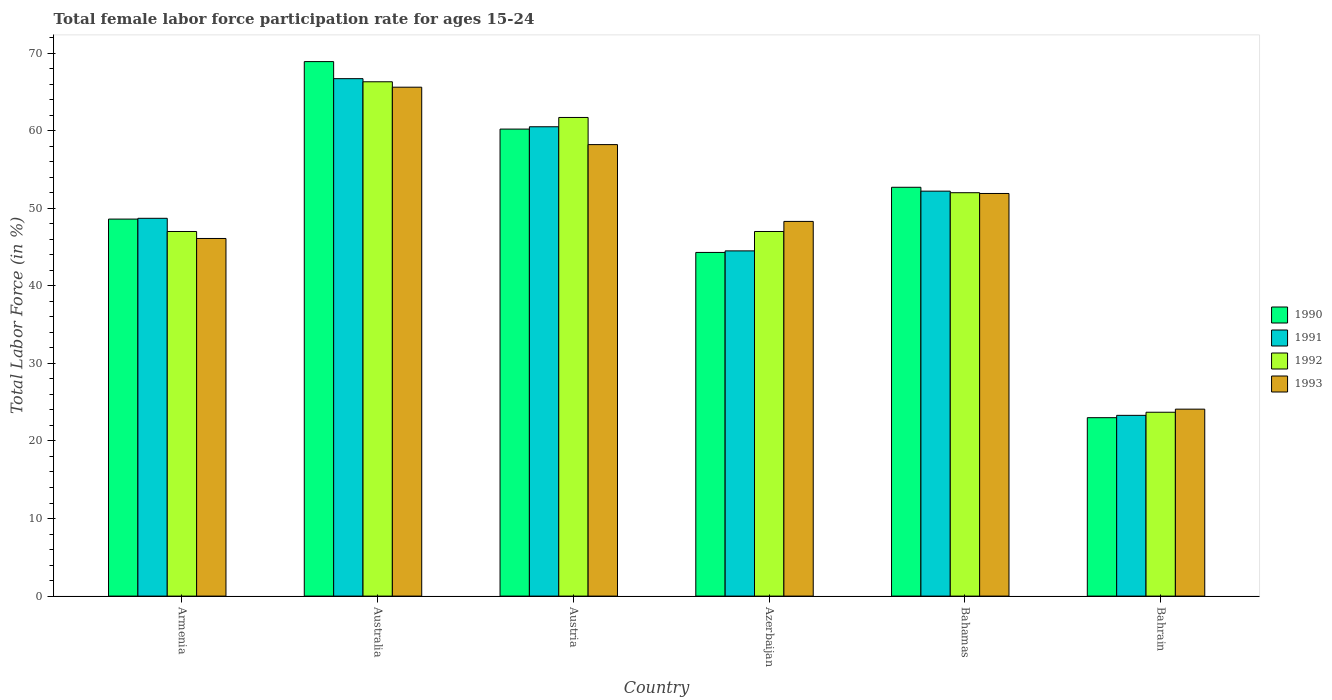How many different coloured bars are there?
Provide a succinct answer. 4. Are the number of bars on each tick of the X-axis equal?
Provide a succinct answer. Yes. How many bars are there on the 1st tick from the right?
Your response must be concise. 4. In how many cases, is the number of bars for a given country not equal to the number of legend labels?
Ensure brevity in your answer.  0. What is the female labor force participation rate in 1991 in Bahamas?
Ensure brevity in your answer.  52.2. Across all countries, what is the maximum female labor force participation rate in 1993?
Your answer should be compact. 65.6. Across all countries, what is the minimum female labor force participation rate in 1993?
Keep it short and to the point. 24.1. In which country was the female labor force participation rate in 1990 minimum?
Provide a short and direct response. Bahrain. What is the total female labor force participation rate in 1991 in the graph?
Offer a very short reply. 295.9. What is the difference between the female labor force participation rate in 1990 in Austria and that in Azerbaijan?
Offer a terse response. 15.9. What is the difference between the female labor force participation rate in 1992 in Austria and the female labor force participation rate in 1990 in Azerbaijan?
Your answer should be very brief. 17.4. What is the average female labor force participation rate in 1992 per country?
Your response must be concise. 49.62. What is the difference between the female labor force participation rate of/in 1991 and female labor force participation rate of/in 1993 in Australia?
Provide a succinct answer. 1.1. What is the ratio of the female labor force participation rate in 1991 in Armenia to that in Azerbaijan?
Make the answer very short. 1.09. Is the female labor force participation rate in 1993 in Armenia less than that in Azerbaijan?
Give a very brief answer. Yes. What is the difference between the highest and the second highest female labor force participation rate in 1992?
Make the answer very short. 14.3. What is the difference between the highest and the lowest female labor force participation rate in 1992?
Offer a terse response. 42.6. Is it the case that in every country, the sum of the female labor force participation rate in 1991 and female labor force participation rate in 1990 is greater than the sum of female labor force participation rate in 1992 and female labor force participation rate in 1993?
Provide a short and direct response. No. What does the 2nd bar from the right in Australia represents?
Give a very brief answer. 1992. Is it the case that in every country, the sum of the female labor force participation rate in 1993 and female labor force participation rate in 1992 is greater than the female labor force participation rate in 1991?
Your answer should be compact. Yes. Are all the bars in the graph horizontal?
Offer a terse response. No. How many countries are there in the graph?
Provide a short and direct response. 6. Are the values on the major ticks of Y-axis written in scientific E-notation?
Provide a succinct answer. No. Does the graph contain any zero values?
Your response must be concise. No. Where does the legend appear in the graph?
Give a very brief answer. Center right. How are the legend labels stacked?
Keep it short and to the point. Vertical. What is the title of the graph?
Provide a short and direct response. Total female labor force participation rate for ages 15-24. What is the Total Labor Force (in %) of 1990 in Armenia?
Make the answer very short. 48.6. What is the Total Labor Force (in %) in 1991 in Armenia?
Make the answer very short. 48.7. What is the Total Labor Force (in %) of 1992 in Armenia?
Your answer should be compact. 47. What is the Total Labor Force (in %) of 1993 in Armenia?
Your answer should be compact. 46.1. What is the Total Labor Force (in %) of 1990 in Australia?
Provide a short and direct response. 68.9. What is the Total Labor Force (in %) of 1991 in Australia?
Your answer should be very brief. 66.7. What is the Total Labor Force (in %) of 1992 in Australia?
Give a very brief answer. 66.3. What is the Total Labor Force (in %) of 1993 in Australia?
Offer a terse response. 65.6. What is the Total Labor Force (in %) of 1990 in Austria?
Make the answer very short. 60.2. What is the Total Labor Force (in %) in 1991 in Austria?
Give a very brief answer. 60.5. What is the Total Labor Force (in %) of 1992 in Austria?
Your response must be concise. 61.7. What is the Total Labor Force (in %) of 1993 in Austria?
Make the answer very short. 58.2. What is the Total Labor Force (in %) of 1990 in Azerbaijan?
Ensure brevity in your answer.  44.3. What is the Total Labor Force (in %) in 1991 in Azerbaijan?
Ensure brevity in your answer.  44.5. What is the Total Labor Force (in %) of 1993 in Azerbaijan?
Offer a terse response. 48.3. What is the Total Labor Force (in %) in 1990 in Bahamas?
Give a very brief answer. 52.7. What is the Total Labor Force (in %) in 1991 in Bahamas?
Make the answer very short. 52.2. What is the Total Labor Force (in %) of 1992 in Bahamas?
Offer a very short reply. 52. What is the Total Labor Force (in %) of 1993 in Bahamas?
Your answer should be very brief. 51.9. What is the Total Labor Force (in %) of 1991 in Bahrain?
Keep it short and to the point. 23.3. What is the Total Labor Force (in %) in 1992 in Bahrain?
Your answer should be compact. 23.7. What is the Total Labor Force (in %) in 1993 in Bahrain?
Your answer should be very brief. 24.1. Across all countries, what is the maximum Total Labor Force (in %) in 1990?
Make the answer very short. 68.9. Across all countries, what is the maximum Total Labor Force (in %) in 1991?
Offer a very short reply. 66.7. Across all countries, what is the maximum Total Labor Force (in %) in 1992?
Your answer should be very brief. 66.3. Across all countries, what is the maximum Total Labor Force (in %) in 1993?
Provide a short and direct response. 65.6. Across all countries, what is the minimum Total Labor Force (in %) of 1990?
Ensure brevity in your answer.  23. Across all countries, what is the minimum Total Labor Force (in %) in 1991?
Keep it short and to the point. 23.3. Across all countries, what is the minimum Total Labor Force (in %) in 1992?
Provide a short and direct response. 23.7. Across all countries, what is the minimum Total Labor Force (in %) of 1993?
Your answer should be compact. 24.1. What is the total Total Labor Force (in %) in 1990 in the graph?
Your response must be concise. 297.7. What is the total Total Labor Force (in %) of 1991 in the graph?
Make the answer very short. 295.9. What is the total Total Labor Force (in %) of 1992 in the graph?
Your answer should be very brief. 297.7. What is the total Total Labor Force (in %) of 1993 in the graph?
Keep it short and to the point. 294.2. What is the difference between the Total Labor Force (in %) in 1990 in Armenia and that in Australia?
Offer a very short reply. -20.3. What is the difference between the Total Labor Force (in %) of 1991 in Armenia and that in Australia?
Offer a very short reply. -18. What is the difference between the Total Labor Force (in %) in 1992 in Armenia and that in Australia?
Keep it short and to the point. -19.3. What is the difference between the Total Labor Force (in %) in 1993 in Armenia and that in Australia?
Give a very brief answer. -19.5. What is the difference between the Total Labor Force (in %) in 1990 in Armenia and that in Austria?
Make the answer very short. -11.6. What is the difference between the Total Labor Force (in %) in 1991 in Armenia and that in Austria?
Provide a succinct answer. -11.8. What is the difference between the Total Labor Force (in %) in 1992 in Armenia and that in Austria?
Make the answer very short. -14.7. What is the difference between the Total Labor Force (in %) of 1990 in Armenia and that in Azerbaijan?
Make the answer very short. 4.3. What is the difference between the Total Labor Force (in %) of 1991 in Armenia and that in Azerbaijan?
Keep it short and to the point. 4.2. What is the difference between the Total Labor Force (in %) in 1992 in Armenia and that in Azerbaijan?
Your response must be concise. 0. What is the difference between the Total Labor Force (in %) in 1990 in Armenia and that in Bahamas?
Make the answer very short. -4.1. What is the difference between the Total Labor Force (in %) of 1990 in Armenia and that in Bahrain?
Offer a very short reply. 25.6. What is the difference between the Total Labor Force (in %) in 1991 in Armenia and that in Bahrain?
Your answer should be compact. 25.4. What is the difference between the Total Labor Force (in %) in 1992 in Armenia and that in Bahrain?
Offer a terse response. 23.3. What is the difference between the Total Labor Force (in %) of 1993 in Armenia and that in Bahrain?
Offer a terse response. 22. What is the difference between the Total Labor Force (in %) in 1993 in Australia and that in Austria?
Your answer should be compact. 7.4. What is the difference between the Total Labor Force (in %) in 1990 in Australia and that in Azerbaijan?
Your answer should be very brief. 24.6. What is the difference between the Total Labor Force (in %) of 1992 in Australia and that in Azerbaijan?
Your response must be concise. 19.3. What is the difference between the Total Labor Force (in %) of 1993 in Australia and that in Azerbaijan?
Make the answer very short. 17.3. What is the difference between the Total Labor Force (in %) of 1990 in Australia and that in Bahamas?
Your response must be concise. 16.2. What is the difference between the Total Labor Force (in %) of 1990 in Australia and that in Bahrain?
Provide a short and direct response. 45.9. What is the difference between the Total Labor Force (in %) of 1991 in Australia and that in Bahrain?
Offer a terse response. 43.4. What is the difference between the Total Labor Force (in %) in 1992 in Australia and that in Bahrain?
Give a very brief answer. 42.6. What is the difference between the Total Labor Force (in %) of 1993 in Australia and that in Bahrain?
Give a very brief answer. 41.5. What is the difference between the Total Labor Force (in %) in 1991 in Austria and that in Azerbaijan?
Your answer should be very brief. 16. What is the difference between the Total Labor Force (in %) in 1990 in Austria and that in Bahamas?
Offer a terse response. 7.5. What is the difference between the Total Labor Force (in %) in 1991 in Austria and that in Bahamas?
Give a very brief answer. 8.3. What is the difference between the Total Labor Force (in %) in 1990 in Austria and that in Bahrain?
Ensure brevity in your answer.  37.2. What is the difference between the Total Labor Force (in %) of 1991 in Austria and that in Bahrain?
Provide a succinct answer. 37.2. What is the difference between the Total Labor Force (in %) of 1993 in Austria and that in Bahrain?
Offer a very short reply. 34.1. What is the difference between the Total Labor Force (in %) of 1991 in Azerbaijan and that in Bahamas?
Provide a succinct answer. -7.7. What is the difference between the Total Labor Force (in %) of 1992 in Azerbaijan and that in Bahamas?
Provide a short and direct response. -5. What is the difference between the Total Labor Force (in %) of 1990 in Azerbaijan and that in Bahrain?
Offer a terse response. 21.3. What is the difference between the Total Labor Force (in %) in 1991 in Azerbaijan and that in Bahrain?
Your response must be concise. 21.2. What is the difference between the Total Labor Force (in %) in 1992 in Azerbaijan and that in Bahrain?
Your answer should be compact. 23.3. What is the difference between the Total Labor Force (in %) in 1993 in Azerbaijan and that in Bahrain?
Provide a succinct answer. 24.2. What is the difference between the Total Labor Force (in %) in 1990 in Bahamas and that in Bahrain?
Ensure brevity in your answer.  29.7. What is the difference between the Total Labor Force (in %) of 1991 in Bahamas and that in Bahrain?
Make the answer very short. 28.9. What is the difference between the Total Labor Force (in %) in 1992 in Bahamas and that in Bahrain?
Offer a very short reply. 28.3. What is the difference between the Total Labor Force (in %) in 1993 in Bahamas and that in Bahrain?
Offer a very short reply. 27.8. What is the difference between the Total Labor Force (in %) of 1990 in Armenia and the Total Labor Force (in %) of 1991 in Australia?
Keep it short and to the point. -18.1. What is the difference between the Total Labor Force (in %) of 1990 in Armenia and the Total Labor Force (in %) of 1992 in Australia?
Your answer should be compact. -17.7. What is the difference between the Total Labor Force (in %) of 1990 in Armenia and the Total Labor Force (in %) of 1993 in Australia?
Your response must be concise. -17. What is the difference between the Total Labor Force (in %) in 1991 in Armenia and the Total Labor Force (in %) in 1992 in Australia?
Offer a very short reply. -17.6. What is the difference between the Total Labor Force (in %) of 1991 in Armenia and the Total Labor Force (in %) of 1993 in Australia?
Give a very brief answer. -16.9. What is the difference between the Total Labor Force (in %) in 1992 in Armenia and the Total Labor Force (in %) in 1993 in Australia?
Provide a short and direct response. -18.6. What is the difference between the Total Labor Force (in %) of 1990 in Armenia and the Total Labor Force (in %) of 1991 in Austria?
Your answer should be very brief. -11.9. What is the difference between the Total Labor Force (in %) in 1990 in Armenia and the Total Labor Force (in %) in 1993 in Austria?
Keep it short and to the point. -9.6. What is the difference between the Total Labor Force (in %) of 1991 in Armenia and the Total Labor Force (in %) of 1992 in Austria?
Ensure brevity in your answer.  -13. What is the difference between the Total Labor Force (in %) in 1992 in Armenia and the Total Labor Force (in %) in 1993 in Austria?
Your answer should be compact. -11.2. What is the difference between the Total Labor Force (in %) of 1991 in Armenia and the Total Labor Force (in %) of 1992 in Azerbaijan?
Provide a succinct answer. 1.7. What is the difference between the Total Labor Force (in %) of 1992 in Armenia and the Total Labor Force (in %) of 1993 in Azerbaijan?
Your answer should be very brief. -1.3. What is the difference between the Total Labor Force (in %) in 1990 in Armenia and the Total Labor Force (in %) in 1991 in Bahamas?
Provide a succinct answer. -3.6. What is the difference between the Total Labor Force (in %) of 1990 in Armenia and the Total Labor Force (in %) of 1993 in Bahamas?
Your answer should be very brief. -3.3. What is the difference between the Total Labor Force (in %) of 1992 in Armenia and the Total Labor Force (in %) of 1993 in Bahamas?
Provide a succinct answer. -4.9. What is the difference between the Total Labor Force (in %) of 1990 in Armenia and the Total Labor Force (in %) of 1991 in Bahrain?
Make the answer very short. 25.3. What is the difference between the Total Labor Force (in %) of 1990 in Armenia and the Total Labor Force (in %) of 1992 in Bahrain?
Make the answer very short. 24.9. What is the difference between the Total Labor Force (in %) of 1990 in Armenia and the Total Labor Force (in %) of 1993 in Bahrain?
Provide a succinct answer. 24.5. What is the difference between the Total Labor Force (in %) of 1991 in Armenia and the Total Labor Force (in %) of 1992 in Bahrain?
Give a very brief answer. 25. What is the difference between the Total Labor Force (in %) in 1991 in Armenia and the Total Labor Force (in %) in 1993 in Bahrain?
Your answer should be very brief. 24.6. What is the difference between the Total Labor Force (in %) in 1992 in Armenia and the Total Labor Force (in %) in 1993 in Bahrain?
Make the answer very short. 22.9. What is the difference between the Total Labor Force (in %) in 1990 in Australia and the Total Labor Force (in %) in 1993 in Austria?
Your response must be concise. 10.7. What is the difference between the Total Labor Force (in %) in 1991 in Australia and the Total Labor Force (in %) in 1992 in Austria?
Give a very brief answer. 5. What is the difference between the Total Labor Force (in %) of 1991 in Australia and the Total Labor Force (in %) of 1993 in Austria?
Your answer should be compact. 8.5. What is the difference between the Total Labor Force (in %) in 1992 in Australia and the Total Labor Force (in %) in 1993 in Austria?
Your response must be concise. 8.1. What is the difference between the Total Labor Force (in %) in 1990 in Australia and the Total Labor Force (in %) in 1991 in Azerbaijan?
Provide a short and direct response. 24.4. What is the difference between the Total Labor Force (in %) of 1990 in Australia and the Total Labor Force (in %) of 1992 in Azerbaijan?
Your answer should be very brief. 21.9. What is the difference between the Total Labor Force (in %) in 1990 in Australia and the Total Labor Force (in %) in 1993 in Azerbaijan?
Provide a succinct answer. 20.6. What is the difference between the Total Labor Force (in %) in 1992 in Australia and the Total Labor Force (in %) in 1993 in Azerbaijan?
Offer a terse response. 18. What is the difference between the Total Labor Force (in %) in 1990 in Australia and the Total Labor Force (in %) in 1991 in Bahamas?
Your answer should be very brief. 16.7. What is the difference between the Total Labor Force (in %) in 1990 in Australia and the Total Labor Force (in %) in 1993 in Bahamas?
Provide a succinct answer. 17. What is the difference between the Total Labor Force (in %) in 1991 in Australia and the Total Labor Force (in %) in 1993 in Bahamas?
Offer a very short reply. 14.8. What is the difference between the Total Labor Force (in %) in 1992 in Australia and the Total Labor Force (in %) in 1993 in Bahamas?
Your response must be concise. 14.4. What is the difference between the Total Labor Force (in %) of 1990 in Australia and the Total Labor Force (in %) of 1991 in Bahrain?
Keep it short and to the point. 45.6. What is the difference between the Total Labor Force (in %) of 1990 in Australia and the Total Labor Force (in %) of 1992 in Bahrain?
Give a very brief answer. 45.2. What is the difference between the Total Labor Force (in %) in 1990 in Australia and the Total Labor Force (in %) in 1993 in Bahrain?
Offer a very short reply. 44.8. What is the difference between the Total Labor Force (in %) of 1991 in Australia and the Total Labor Force (in %) of 1993 in Bahrain?
Your answer should be very brief. 42.6. What is the difference between the Total Labor Force (in %) of 1992 in Australia and the Total Labor Force (in %) of 1993 in Bahrain?
Give a very brief answer. 42.2. What is the difference between the Total Labor Force (in %) in 1990 in Austria and the Total Labor Force (in %) in 1992 in Azerbaijan?
Your response must be concise. 13.2. What is the difference between the Total Labor Force (in %) in 1990 in Austria and the Total Labor Force (in %) in 1992 in Bahamas?
Offer a terse response. 8.2. What is the difference between the Total Labor Force (in %) of 1992 in Austria and the Total Labor Force (in %) of 1993 in Bahamas?
Provide a short and direct response. 9.8. What is the difference between the Total Labor Force (in %) of 1990 in Austria and the Total Labor Force (in %) of 1991 in Bahrain?
Offer a very short reply. 36.9. What is the difference between the Total Labor Force (in %) in 1990 in Austria and the Total Labor Force (in %) in 1992 in Bahrain?
Ensure brevity in your answer.  36.5. What is the difference between the Total Labor Force (in %) in 1990 in Austria and the Total Labor Force (in %) in 1993 in Bahrain?
Your answer should be very brief. 36.1. What is the difference between the Total Labor Force (in %) of 1991 in Austria and the Total Labor Force (in %) of 1992 in Bahrain?
Provide a succinct answer. 36.8. What is the difference between the Total Labor Force (in %) of 1991 in Austria and the Total Labor Force (in %) of 1993 in Bahrain?
Provide a short and direct response. 36.4. What is the difference between the Total Labor Force (in %) in 1992 in Austria and the Total Labor Force (in %) in 1993 in Bahrain?
Give a very brief answer. 37.6. What is the difference between the Total Labor Force (in %) of 1990 in Azerbaijan and the Total Labor Force (in %) of 1991 in Bahamas?
Keep it short and to the point. -7.9. What is the difference between the Total Labor Force (in %) of 1991 in Azerbaijan and the Total Labor Force (in %) of 1992 in Bahamas?
Keep it short and to the point. -7.5. What is the difference between the Total Labor Force (in %) of 1991 in Azerbaijan and the Total Labor Force (in %) of 1993 in Bahamas?
Your answer should be compact. -7.4. What is the difference between the Total Labor Force (in %) of 1990 in Azerbaijan and the Total Labor Force (in %) of 1991 in Bahrain?
Ensure brevity in your answer.  21. What is the difference between the Total Labor Force (in %) of 1990 in Azerbaijan and the Total Labor Force (in %) of 1992 in Bahrain?
Offer a very short reply. 20.6. What is the difference between the Total Labor Force (in %) in 1990 in Azerbaijan and the Total Labor Force (in %) in 1993 in Bahrain?
Provide a succinct answer. 20.2. What is the difference between the Total Labor Force (in %) of 1991 in Azerbaijan and the Total Labor Force (in %) of 1992 in Bahrain?
Provide a succinct answer. 20.8. What is the difference between the Total Labor Force (in %) of 1991 in Azerbaijan and the Total Labor Force (in %) of 1993 in Bahrain?
Your answer should be compact. 20.4. What is the difference between the Total Labor Force (in %) of 1992 in Azerbaijan and the Total Labor Force (in %) of 1993 in Bahrain?
Your answer should be compact. 22.9. What is the difference between the Total Labor Force (in %) in 1990 in Bahamas and the Total Labor Force (in %) in 1991 in Bahrain?
Offer a terse response. 29.4. What is the difference between the Total Labor Force (in %) in 1990 in Bahamas and the Total Labor Force (in %) in 1993 in Bahrain?
Keep it short and to the point. 28.6. What is the difference between the Total Labor Force (in %) of 1991 in Bahamas and the Total Labor Force (in %) of 1992 in Bahrain?
Your answer should be very brief. 28.5. What is the difference between the Total Labor Force (in %) of 1991 in Bahamas and the Total Labor Force (in %) of 1993 in Bahrain?
Provide a succinct answer. 28.1. What is the difference between the Total Labor Force (in %) in 1992 in Bahamas and the Total Labor Force (in %) in 1993 in Bahrain?
Provide a short and direct response. 27.9. What is the average Total Labor Force (in %) of 1990 per country?
Make the answer very short. 49.62. What is the average Total Labor Force (in %) in 1991 per country?
Give a very brief answer. 49.32. What is the average Total Labor Force (in %) in 1992 per country?
Give a very brief answer. 49.62. What is the average Total Labor Force (in %) in 1993 per country?
Provide a succinct answer. 49.03. What is the difference between the Total Labor Force (in %) in 1990 and Total Labor Force (in %) in 1992 in Armenia?
Offer a terse response. 1.6. What is the difference between the Total Labor Force (in %) of 1991 and Total Labor Force (in %) of 1992 in Armenia?
Provide a succinct answer. 1.7. What is the difference between the Total Labor Force (in %) in 1992 and Total Labor Force (in %) in 1993 in Armenia?
Make the answer very short. 0.9. What is the difference between the Total Labor Force (in %) of 1990 and Total Labor Force (in %) of 1991 in Australia?
Your response must be concise. 2.2. What is the difference between the Total Labor Force (in %) of 1990 and Total Labor Force (in %) of 1992 in Australia?
Ensure brevity in your answer.  2.6. What is the difference between the Total Labor Force (in %) in 1990 and Total Labor Force (in %) in 1993 in Australia?
Give a very brief answer. 3.3. What is the difference between the Total Labor Force (in %) of 1991 and Total Labor Force (in %) of 1993 in Australia?
Provide a short and direct response. 1.1. What is the difference between the Total Labor Force (in %) of 1990 and Total Labor Force (in %) of 1992 in Austria?
Your answer should be compact. -1.5. What is the difference between the Total Labor Force (in %) of 1991 and Total Labor Force (in %) of 1992 in Austria?
Offer a terse response. -1.2. What is the difference between the Total Labor Force (in %) in 1991 and Total Labor Force (in %) in 1993 in Austria?
Your response must be concise. 2.3. What is the difference between the Total Labor Force (in %) in 1992 and Total Labor Force (in %) in 1993 in Austria?
Your response must be concise. 3.5. What is the difference between the Total Labor Force (in %) of 1990 and Total Labor Force (in %) of 1992 in Azerbaijan?
Give a very brief answer. -2.7. What is the difference between the Total Labor Force (in %) of 1991 and Total Labor Force (in %) of 1993 in Azerbaijan?
Your answer should be very brief. -3.8. What is the difference between the Total Labor Force (in %) in 1991 and Total Labor Force (in %) in 1993 in Bahamas?
Offer a very short reply. 0.3. What is the difference between the Total Labor Force (in %) of 1990 and Total Labor Force (in %) of 1992 in Bahrain?
Ensure brevity in your answer.  -0.7. What is the difference between the Total Labor Force (in %) of 1990 and Total Labor Force (in %) of 1993 in Bahrain?
Ensure brevity in your answer.  -1.1. What is the difference between the Total Labor Force (in %) of 1991 and Total Labor Force (in %) of 1993 in Bahrain?
Your answer should be compact. -0.8. What is the difference between the Total Labor Force (in %) of 1992 and Total Labor Force (in %) of 1993 in Bahrain?
Keep it short and to the point. -0.4. What is the ratio of the Total Labor Force (in %) in 1990 in Armenia to that in Australia?
Provide a succinct answer. 0.71. What is the ratio of the Total Labor Force (in %) in 1991 in Armenia to that in Australia?
Your answer should be very brief. 0.73. What is the ratio of the Total Labor Force (in %) of 1992 in Armenia to that in Australia?
Provide a short and direct response. 0.71. What is the ratio of the Total Labor Force (in %) in 1993 in Armenia to that in Australia?
Your response must be concise. 0.7. What is the ratio of the Total Labor Force (in %) of 1990 in Armenia to that in Austria?
Your answer should be compact. 0.81. What is the ratio of the Total Labor Force (in %) of 1991 in Armenia to that in Austria?
Offer a terse response. 0.81. What is the ratio of the Total Labor Force (in %) of 1992 in Armenia to that in Austria?
Your response must be concise. 0.76. What is the ratio of the Total Labor Force (in %) in 1993 in Armenia to that in Austria?
Keep it short and to the point. 0.79. What is the ratio of the Total Labor Force (in %) in 1990 in Armenia to that in Azerbaijan?
Your answer should be compact. 1.1. What is the ratio of the Total Labor Force (in %) of 1991 in Armenia to that in Azerbaijan?
Keep it short and to the point. 1.09. What is the ratio of the Total Labor Force (in %) of 1993 in Armenia to that in Azerbaijan?
Offer a very short reply. 0.95. What is the ratio of the Total Labor Force (in %) in 1990 in Armenia to that in Bahamas?
Your answer should be very brief. 0.92. What is the ratio of the Total Labor Force (in %) of 1991 in Armenia to that in Bahamas?
Provide a succinct answer. 0.93. What is the ratio of the Total Labor Force (in %) of 1992 in Armenia to that in Bahamas?
Provide a succinct answer. 0.9. What is the ratio of the Total Labor Force (in %) of 1993 in Armenia to that in Bahamas?
Keep it short and to the point. 0.89. What is the ratio of the Total Labor Force (in %) in 1990 in Armenia to that in Bahrain?
Ensure brevity in your answer.  2.11. What is the ratio of the Total Labor Force (in %) in 1991 in Armenia to that in Bahrain?
Your answer should be compact. 2.09. What is the ratio of the Total Labor Force (in %) of 1992 in Armenia to that in Bahrain?
Your answer should be very brief. 1.98. What is the ratio of the Total Labor Force (in %) in 1993 in Armenia to that in Bahrain?
Your response must be concise. 1.91. What is the ratio of the Total Labor Force (in %) in 1990 in Australia to that in Austria?
Keep it short and to the point. 1.14. What is the ratio of the Total Labor Force (in %) in 1991 in Australia to that in Austria?
Give a very brief answer. 1.1. What is the ratio of the Total Labor Force (in %) in 1992 in Australia to that in Austria?
Your response must be concise. 1.07. What is the ratio of the Total Labor Force (in %) in 1993 in Australia to that in Austria?
Make the answer very short. 1.13. What is the ratio of the Total Labor Force (in %) of 1990 in Australia to that in Azerbaijan?
Make the answer very short. 1.56. What is the ratio of the Total Labor Force (in %) in 1991 in Australia to that in Azerbaijan?
Ensure brevity in your answer.  1.5. What is the ratio of the Total Labor Force (in %) of 1992 in Australia to that in Azerbaijan?
Give a very brief answer. 1.41. What is the ratio of the Total Labor Force (in %) in 1993 in Australia to that in Azerbaijan?
Provide a succinct answer. 1.36. What is the ratio of the Total Labor Force (in %) of 1990 in Australia to that in Bahamas?
Provide a succinct answer. 1.31. What is the ratio of the Total Labor Force (in %) of 1991 in Australia to that in Bahamas?
Your answer should be compact. 1.28. What is the ratio of the Total Labor Force (in %) in 1992 in Australia to that in Bahamas?
Your response must be concise. 1.27. What is the ratio of the Total Labor Force (in %) in 1993 in Australia to that in Bahamas?
Provide a succinct answer. 1.26. What is the ratio of the Total Labor Force (in %) of 1990 in Australia to that in Bahrain?
Make the answer very short. 3. What is the ratio of the Total Labor Force (in %) in 1991 in Australia to that in Bahrain?
Your response must be concise. 2.86. What is the ratio of the Total Labor Force (in %) in 1992 in Australia to that in Bahrain?
Your answer should be compact. 2.8. What is the ratio of the Total Labor Force (in %) of 1993 in Australia to that in Bahrain?
Provide a short and direct response. 2.72. What is the ratio of the Total Labor Force (in %) of 1990 in Austria to that in Azerbaijan?
Offer a very short reply. 1.36. What is the ratio of the Total Labor Force (in %) in 1991 in Austria to that in Azerbaijan?
Offer a very short reply. 1.36. What is the ratio of the Total Labor Force (in %) of 1992 in Austria to that in Azerbaijan?
Offer a very short reply. 1.31. What is the ratio of the Total Labor Force (in %) of 1993 in Austria to that in Azerbaijan?
Provide a short and direct response. 1.21. What is the ratio of the Total Labor Force (in %) in 1990 in Austria to that in Bahamas?
Ensure brevity in your answer.  1.14. What is the ratio of the Total Labor Force (in %) of 1991 in Austria to that in Bahamas?
Your answer should be compact. 1.16. What is the ratio of the Total Labor Force (in %) of 1992 in Austria to that in Bahamas?
Your answer should be very brief. 1.19. What is the ratio of the Total Labor Force (in %) in 1993 in Austria to that in Bahamas?
Give a very brief answer. 1.12. What is the ratio of the Total Labor Force (in %) of 1990 in Austria to that in Bahrain?
Give a very brief answer. 2.62. What is the ratio of the Total Labor Force (in %) in 1991 in Austria to that in Bahrain?
Offer a terse response. 2.6. What is the ratio of the Total Labor Force (in %) of 1992 in Austria to that in Bahrain?
Ensure brevity in your answer.  2.6. What is the ratio of the Total Labor Force (in %) in 1993 in Austria to that in Bahrain?
Give a very brief answer. 2.41. What is the ratio of the Total Labor Force (in %) in 1990 in Azerbaijan to that in Bahamas?
Your response must be concise. 0.84. What is the ratio of the Total Labor Force (in %) in 1991 in Azerbaijan to that in Bahamas?
Keep it short and to the point. 0.85. What is the ratio of the Total Labor Force (in %) of 1992 in Azerbaijan to that in Bahamas?
Your response must be concise. 0.9. What is the ratio of the Total Labor Force (in %) in 1993 in Azerbaijan to that in Bahamas?
Make the answer very short. 0.93. What is the ratio of the Total Labor Force (in %) in 1990 in Azerbaijan to that in Bahrain?
Offer a very short reply. 1.93. What is the ratio of the Total Labor Force (in %) of 1991 in Azerbaijan to that in Bahrain?
Provide a short and direct response. 1.91. What is the ratio of the Total Labor Force (in %) in 1992 in Azerbaijan to that in Bahrain?
Provide a succinct answer. 1.98. What is the ratio of the Total Labor Force (in %) of 1993 in Azerbaijan to that in Bahrain?
Your response must be concise. 2. What is the ratio of the Total Labor Force (in %) in 1990 in Bahamas to that in Bahrain?
Your response must be concise. 2.29. What is the ratio of the Total Labor Force (in %) of 1991 in Bahamas to that in Bahrain?
Provide a short and direct response. 2.24. What is the ratio of the Total Labor Force (in %) in 1992 in Bahamas to that in Bahrain?
Keep it short and to the point. 2.19. What is the ratio of the Total Labor Force (in %) in 1993 in Bahamas to that in Bahrain?
Make the answer very short. 2.15. What is the difference between the highest and the second highest Total Labor Force (in %) of 1990?
Your answer should be very brief. 8.7. What is the difference between the highest and the second highest Total Labor Force (in %) in 1991?
Offer a very short reply. 6.2. What is the difference between the highest and the second highest Total Labor Force (in %) in 1992?
Provide a succinct answer. 4.6. What is the difference between the highest and the second highest Total Labor Force (in %) in 1993?
Offer a very short reply. 7.4. What is the difference between the highest and the lowest Total Labor Force (in %) of 1990?
Offer a terse response. 45.9. What is the difference between the highest and the lowest Total Labor Force (in %) of 1991?
Your answer should be very brief. 43.4. What is the difference between the highest and the lowest Total Labor Force (in %) in 1992?
Your response must be concise. 42.6. What is the difference between the highest and the lowest Total Labor Force (in %) of 1993?
Provide a short and direct response. 41.5. 